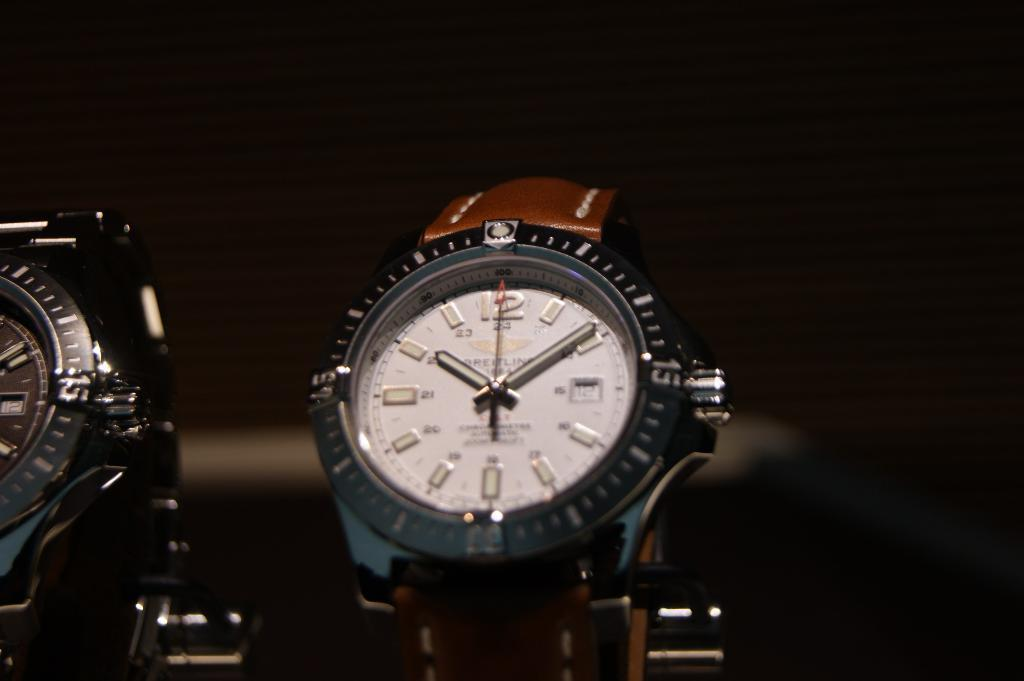<image>
Create a compact narrative representing the image presented. Two shiny Breitling Watches on display with a dark background. 